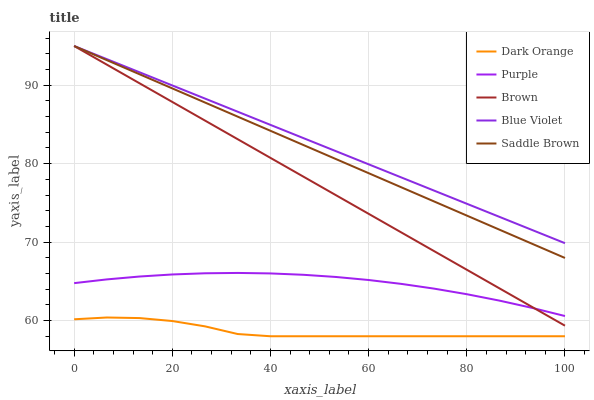Does Dark Orange have the minimum area under the curve?
Answer yes or no. Yes. Does Saddle Brown have the minimum area under the curve?
Answer yes or no. No. Does Saddle Brown have the maximum area under the curve?
Answer yes or no. No. Is Dark Orange the roughest?
Answer yes or no. Yes. Is Saddle Brown the smoothest?
Answer yes or no. No. Is Saddle Brown the roughest?
Answer yes or no. No. Does Saddle Brown have the lowest value?
Answer yes or no. No. Does Dark Orange have the highest value?
Answer yes or no. No. Is Purple less than Saddle Brown?
Answer yes or no. Yes. Is Purple greater than Dark Orange?
Answer yes or no. Yes. Does Purple intersect Saddle Brown?
Answer yes or no. No. 